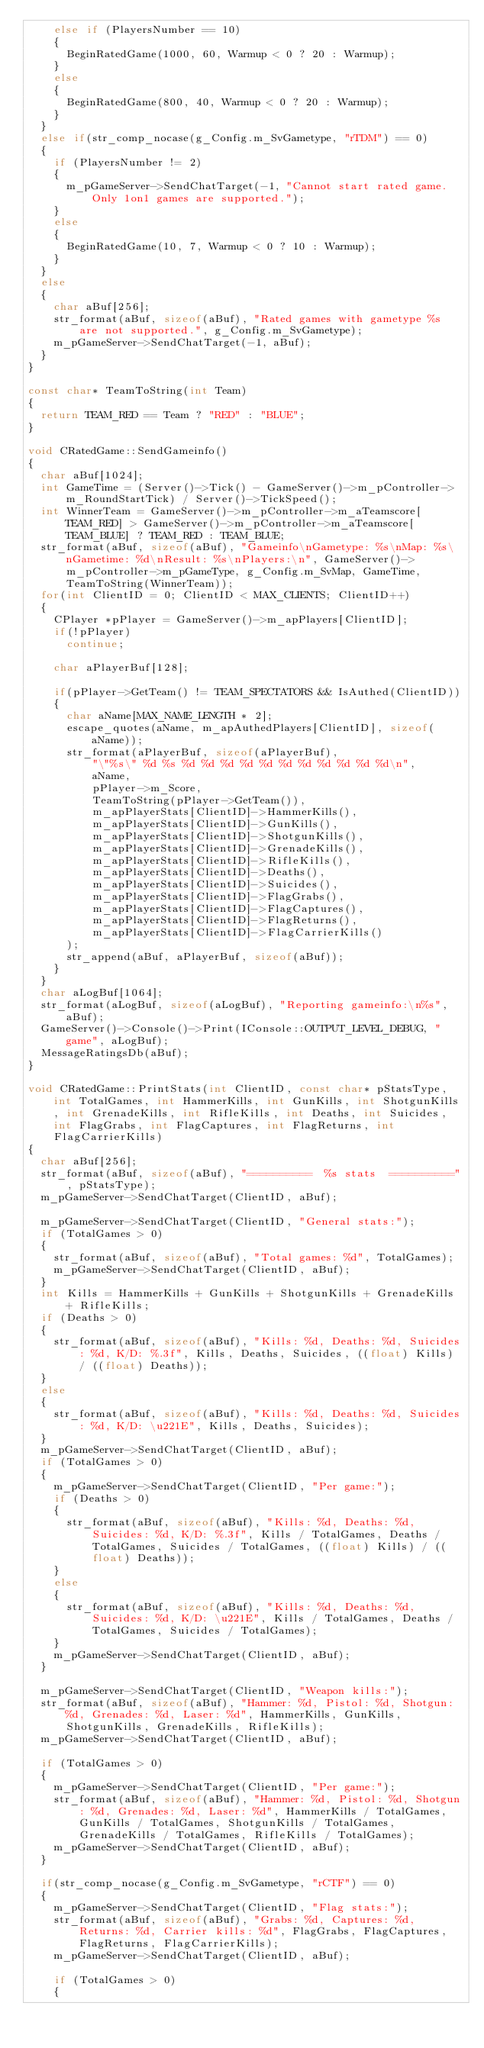<code> <loc_0><loc_0><loc_500><loc_500><_C++_>		else if (PlayersNumber == 10)
		{
			BeginRatedGame(1000, 60, Warmup < 0 ? 20 : Warmup);
		}
		else
		{
			BeginRatedGame(800, 40, Warmup < 0 ? 20 : Warmup);
		}
	}
	else if(str_comp_nocase(g_Config.m_SvGametype, "rTDM") == 0)
	{
		if (PlayersNumber != 2)
		{
			m_pGameServer->SendChatTarget(-1, "Cannot start rated game. Only 1on1 games are supported.");
		}
		else
		{
			BeginRatedGame(10, 7, Warmup < 0 ? 10 : Warmup);
		}
	}
	else
	{
		char aBuf[256];
		str_format(aBuf, sizeof(aBuf), "Rated games with gametype %s are not supported.", g_Config.m_SvGametype);
		m_pGameServer->SendChatTarget(-1, aBuf);
	}
}

const char* TeamToString(int Team)
{
	return TEAM_RED == Team ? "RED" : "BLUE";
}

void CRatedGame::SendGameinfo()
{
	char aBuf[1024];
	int GameTime = (Server()->Tick() - GameServer()->m_pController->m_RoundStartTick) / Server()->TickSpeed();
	int WinnerTeam = GameServer()->m_pController->m_aTeamscore[TEAM_RED] > GameServer()->m_pController->m_aTeamscore[TEAM_BLUE] ? TEAM_RED : TEAM_BLUE;
	str_format(aBuf, sizeof(aBuf), "Gameinfo\nGametype: %s\nMap: %s\nGametime: %d\nResult: %s\nPlayers:\n", GameServer()->m_pController->m_pGameType, g_Config.m_SvMap, GameTime, TeamToString(WinnerTeam));
	for(int ClientID = 0; ClientID < MAX_CLIENTS; ClientID++)
	{
		CPlayer *pPlayer = GameServer()->m_apPlayers[ClientID];
		if(!pPlayer)
			continue;

		char aPlayerBuf[128];

		if(pPlayer->GetTeam() != TEAM_SPECTATORS && IsAuthed(ClientID))
		{
			char aName[MAX_NAME_LENGTH * 2];
			escape_quotes(aName, m_apAuthedPlayers[ClientID], sizeof(aName));
			str_format(aPlayerBuf, sizeof(aPlayerBuf),
					"\"%s\" %d %s %d %d %d %d %d %d %d %d %d %d %d\n",
					aName,
					pPlayer->m_Score,
					TeamToString(pPlayer->GetTeam()),
					m_apPlayerStats[ClientID]->HammerKills(),
					m_apPlayerStats[ClientID]->GunKills(),
					m_apPlayerStats[ClientID]->ShotgunKills(),
					m_apPlayerStats[ClientID]->GrenadeKills(),
					m_apPlayerStats[ClientID]->RifleKills(),
					m_apPlayerStats[ClientID]->Deaths(),
					m_apPlayerStats[ClientID]->Suicides(),
					m_apPlayerStats[ClientID]->FlagGrabs(),
					m_apPlayerStats[ClientID]->FlagCaptures(),
					m_apPlayerStats[ClientID]->FlagReturns(),
					m_apPlayerStats[ClientID]->FlagCarrierKills()
			);
			str_append(aBuf, aPlayerBuf, sizeof(aBuf));
		}
	}
	char aLogBuf[1064];
	str_format(aLogBuf, sizeof(aLogBuf), "Reporting gameinfo:\n%s", aBuf);
	GameServer()->Console()->Print(IConsole::OUTPUT_LEVEL_DEBUG, "game", aLogBuf);
	MessageRatingsDb(aBuf);
}

void CRatedGame::PrintStats(int ClientID, const char* pStatsType, int TotalGames, int HammerKills, int GunKills, int ShotgunKills, int GrenadeKills, int RifleKills, int Deaths, int Suicides, int FlagGrabs, int FlagCaptures, int FlagReturns, int FlagCarrierKills)
{
	char aBuf[256];
	str_format(aBuf, sizeof(aBuf), "==========  %s stats  ==========", pStatsType);
	m_pGameServer->SendChatTarget(ClientID, aBuf);

	m_pGameServer->SendChatTarget(ClientID, "General stats:");
	if (TotalGames > 0)
	{
		str_format(aBuf, sizeof(aBuf), "Total games: %d", TotalGames);
		m_pGameServer->SendChatTarget(ClientID, aBuf);
	}
	int Kills = HammerKills + GunKills + ShotgunKills + GrenadeKills + RifleKills;
	if (Deaths > 0)
	{
		str_format(aBuf, sizeof(aBuf), "Kills: %d, Deaths: %d, Suicides: %d, K/D: %.3f", Kills, Deaths, Suicides, ((float) Kills) / ((float) Deaths));
	}
	else
	{
		str_format(aBuf, sizeof(aBuf), "Kills: %d, Deaths: %d, Suicides: %d, K/D: \u221E", Kills, Deaths, Suicides);
	}
	m_pGameServer->SendChatTarget(ClientID, aBuf);
	if (TotalGames > 0)
	{
		m_pGameServer->SendChatTarget(ClientID, "Per game:");
		if (Deaths > 0)
		{
			str_format(aBuf, sizeof(aBuf), "Kills: %d, Deaths: %d, Suicides: %d, K/D: %.3f", Kills / TotalGames, Deaths / TotalGames, Suicides / TotalGames, ((float) Kills) / ((float) Deaths));
		}
		else
		{
			str_format(aBuf, sizeof(aBuf), "Kills: %d, Deaths: %d, Suicides: %d, K/D: \u221E", Kills / TotalGames, Deaths / TotalGames, Suicides / TotalGames);
		}
		m_pGameServer->SendChatTarget(ClientID, aBuf);
	}

	m_pGameServer->SendChatTarget(ClientID, "Weapon kills:");
	str_format(aBuf, sizeof(aBuf), "Hammer: %d, Pistol: %d, Shotgun: %d, Grenades: %d, Laser: %d", HammerKills, GunKills, ShotgunKills, GrenadeKills, RifleKills);
	m_pGameServer->SendChatTarget(ClientID, aBuf);

	if (TotalGames > 0)
	{
		m_pGameServer->SendChatTarget(ClientID, "Per game:");
		str_format(aBuf, sizeof(aBuf), "Hammer: %d, Pistol: %d, Shotgun: %d, Grenades: %d, Laser: %d", HammerKills / TotalGames, GunKills / TotalGames, ShotgunKills / TotalGames, GrenadeKills / TotalGames, RifleKills / TotalGames);
		m_pGameServer->SendChatTarget(ClientID, aBuf);
	}

	if(str_comp_nocase(g_Config.m_SvGametype, "rCTF") == 0)
	{
		m_pGameServer->SendChatTarget(ClientID, "Flag stats:");
		str_format(aBuf, sizeof(aBuf), "Grabs: %d, Captures: %d, Returns: %d, Carrier kills: %d", FlagGrabs, FlagCaptures, FlagReturns, FlagCarrierKills);
		m_pGameServer->SendChatTarget(ClientID, aBuf);

		if (TotalGames > 0)
		{</code> 